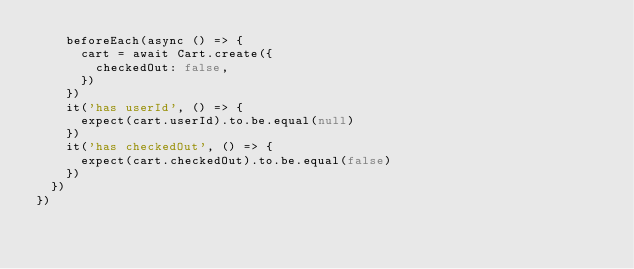<code> <loc_0><loc_0><loc_500><loc_500><_JavaScript_>    beforeEach(async () => {
      cart = await Cart.create({
        checkedOut: false,
      })
    })
    it('has userId', () => {
      expect(cart.userId).to.be.equal(null)
    })
    it('has checkedOut', () => {
      expect(cart.checkedOut).to.be.equal(false)
    })
  })
})
</code> 